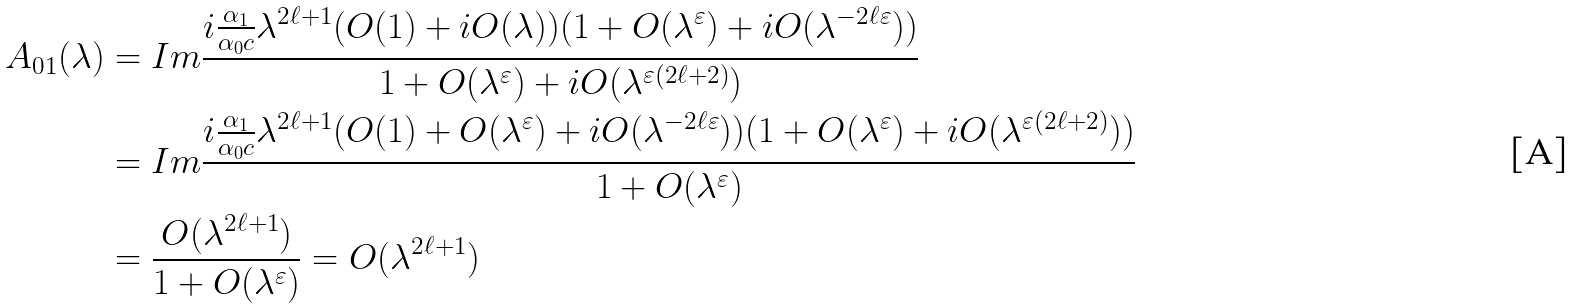<formula> <loc_0><loc_0><loc_500><loc_500>A _ { 0 1 } ( \lambda ) & = I m \frac { i \frac { \alpha _ { 1 } } { \alpha _ { 0 } c } \lambda ^ { 2 \ell + 1 } ( O ( 1 ) + i O ( \lambda ) ) ( 1 + O ( \lambda ^ { \varepsilon } ) + i O ( \lambda ^ { - 2 \ell \varepsilon } ) ) } { 1 + O ( \lambda ^ { \varepsilon } ) + i O ( \lambda ^ { \varepsilon ( 2 \ell + 2 ) } ) } \\ & = I m \frac { i \frac { \alpha _ { 1 } } { \alpha _ { 0 } c } \lambda ^ { 2 \ell + 1 } ( O ( 1 ) + O ( \lambda ^ { \varepsilon } ) + i O ( \lambda ^ { - 2 \ell \varepsilon } ) ) ( 1 + O ( \lambda ^ { \varepsilon } ) + i O ( \lambda ^ { \varepsilon ( 2 \ell + 2 ) } ) ) } { 1 + O ( \lambda ^ { \varepsilon } ) } \\ & = \frac { O ( \lambda ^ { 2 \ell + 1 } ) } { 1 + O ( \lambda ^ { \varepsilon } ) } = O ( \lambda ^ { 2 \ell + 1 } )</formula> 